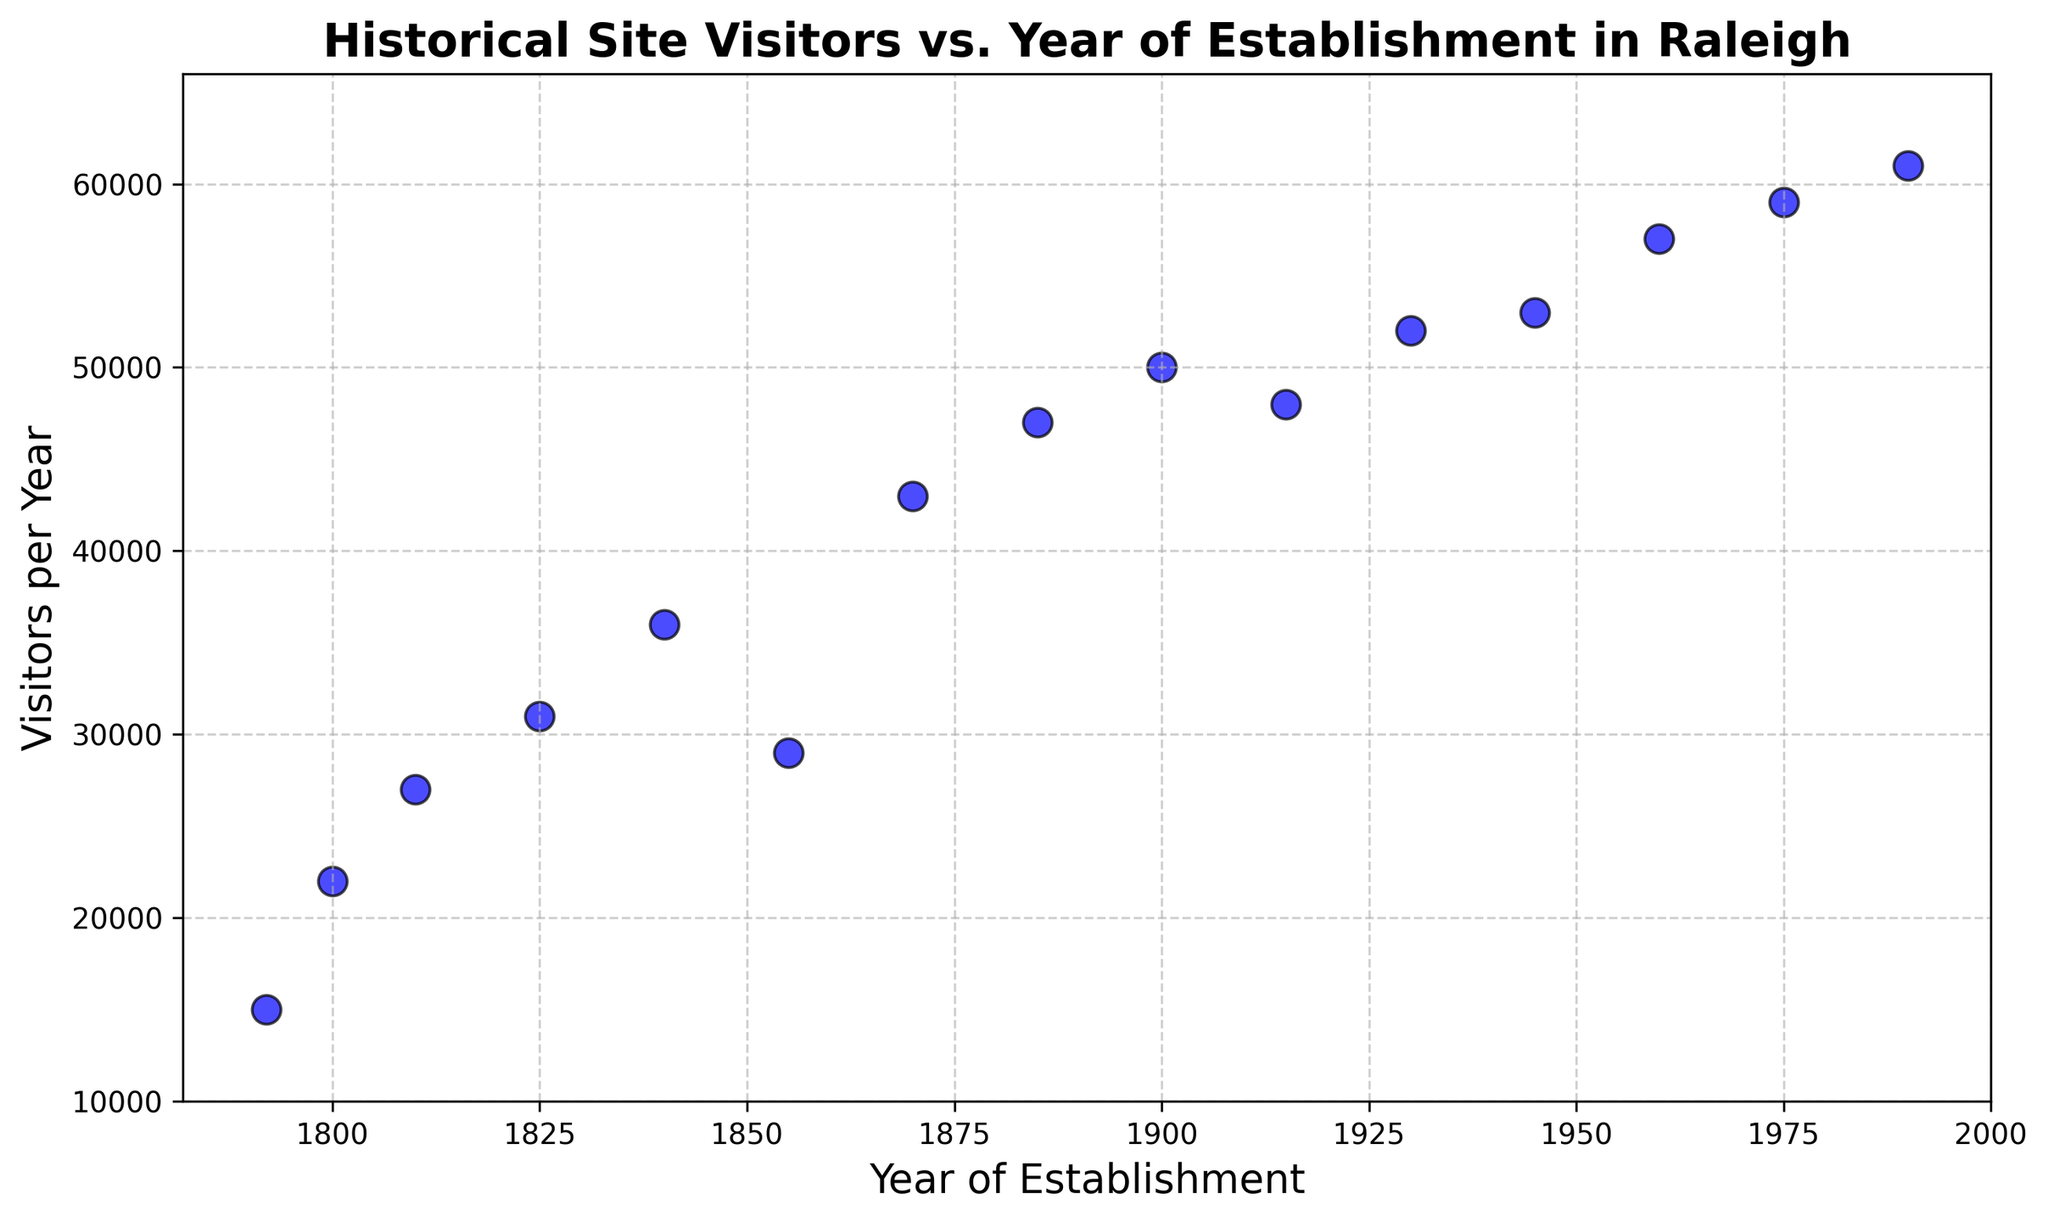What is the general trend in the number of visitors with the year of establishment? The general trend shows an increase in the number of visitors to historical sites established in more recent years. Each newer historical site tends to have more visitors per year compared to older sites.
Answer: Increasing Which historical site has the highest number of visitors per year? The site established in 1990 has the highest number of visitors per year. This can be identified by locating the highest point on the y-axis within the scatter points.
Answer: 1990 How many visitors does the site established in 1855 attract per year? At the year 1855 on the x-axis, we find the corresponding point on the y-axis, which is at 29,000 visitors per year.
Answer: 29,000 Compare the number of visitors between the sites established in 1800 and 1900. Which one has more visitors? Referring to the scatter points, the site from 1900 has 50,000 visitors per year, while the site from 1800 has 22,000 visitors per year. Thus, the site established in 1900 has more visitors.
Answer: 1900 What is the average number of visitors per year for sites established between 1800 and 1900 (inclusive)? The relevant years are 1800, 1810, 1825, 1840, 1855, 1870, 1885, and 1900. The visitors per year are 22,000, 27,000, 31,000, 36,000, 29,000, 43,000, 47,000, and 50,000 respectively. Summing these values gives 285,000, and there are 8 points, so the average is 285,000 / 8 = 35,625.
Answer: 35,625 Which site has fewer visitors, the one established in 1930 or the one established in 1960? The site established in 1930 has 52,000 visitors per year, while the one established in 1960 has 57,000 visitors per year. Thus, the site from 1930 has fewer visitors.
Answer: 1930 What's the median number of visitors per year for all the historical sites? Arranging the number of visitors per year in ascending order: 15,000, 22,000, 27,000, 29,000, 31,000, 36,000, 43,000, 47,000, 48,000, 50,000, 52,000, 53,000, 57,000, 59,000, 61,000. With 15 numbers, the median is the 8th number, which is 47,000.
Answer: 47,000 